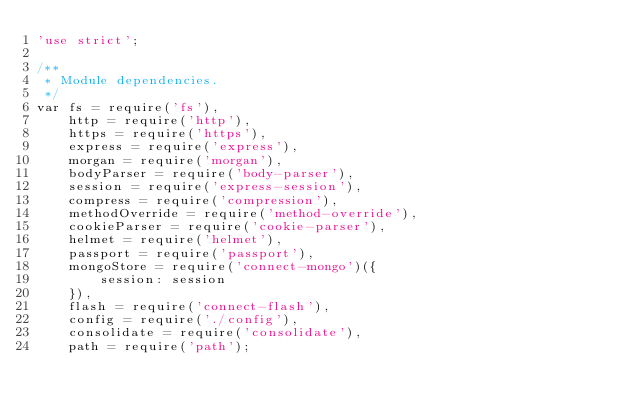Convert code to text. <code><loc_0><loc_0><loc_500><loc_500><_JavaScript_>'use strict';

/**
 * Module dependencies.
 */
var fs = require('fs'),
	http = require('http'),
	https = require('https'),
	express = require('express'),
	morgan = require('morgan'),
	bodyParser = require('body-parser'),
	session = require('express-session'),
	compress = require('compression'),
	methodOverride = require('method-override'),
	cookieParser = require('cookie-parser'),
	helmet = require('helmet'),
	passport = require('passport'),
	mongoStore = require('connect-mongo')({
		session: session
	}),
	flash = require('connect-flash'),
	config = require('./config'),
	consolidate = require('consolidate'),
	path = require('path');</code> 